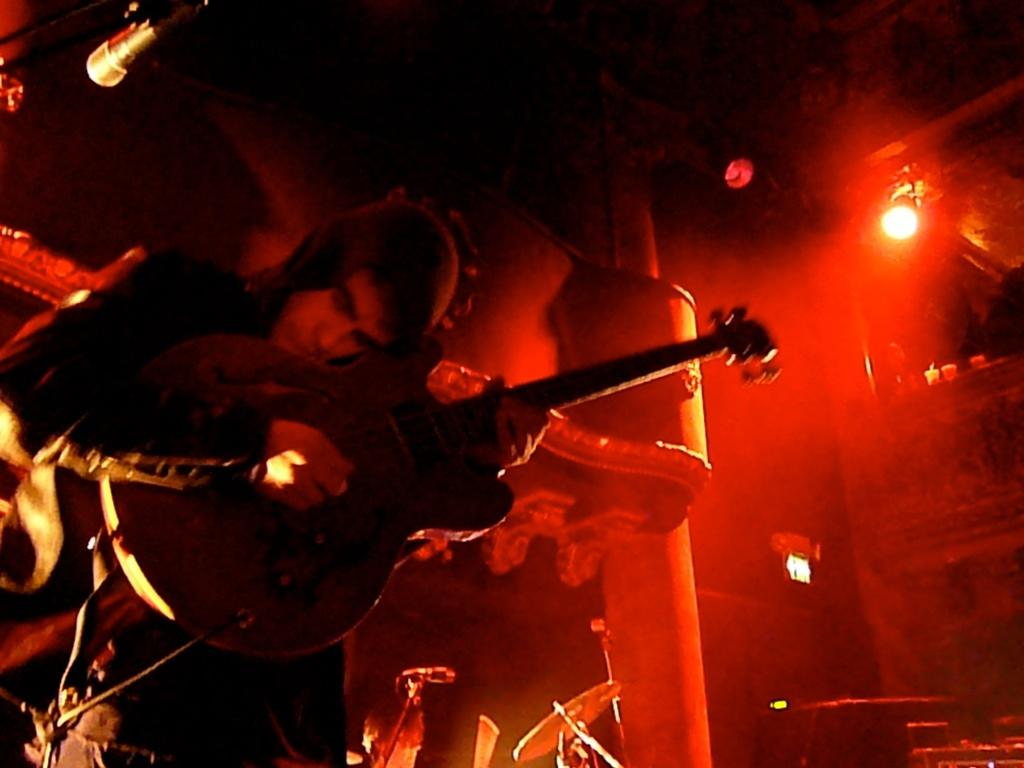What is the main subject of the image? There is a person in the image. What is the person wearing? The person is wearing a black color jacket. What is the person doing in the image? The person is playing a guitar. What color light can be seen in the background of the image? There is red color light in the background of the image. What position does the person hold while writing in the image? There is no writing activity depicted in the image; the person is playing a guitar. What type of hair does the person have in the image? The provided facts do not mention the person's hair, so we cannot determine their hair type from the image. 